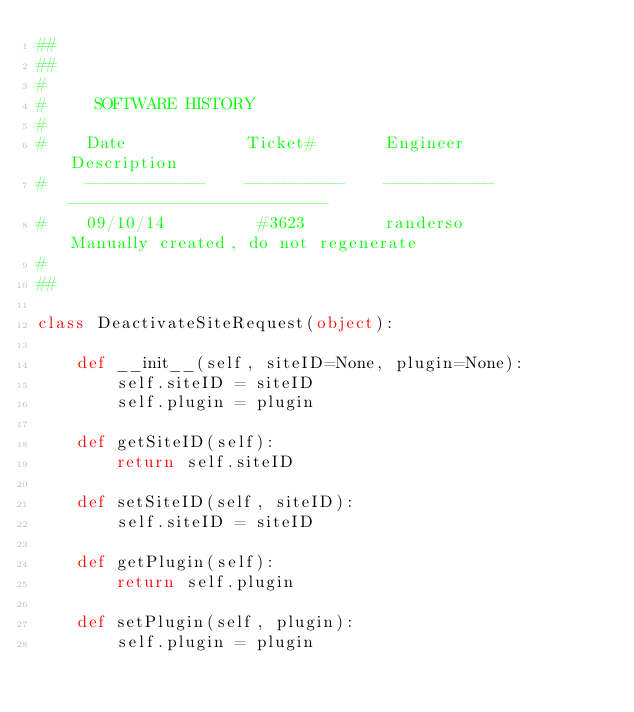<code> <loc_0><loc_0><loc_500><loc_500><_Python_>##
##
#
#     SOFTWARE HISTORY
#
#    Date            Ticket#       Engineer       Description
#    ------------    ----------    -----------    --------------------------
#    09/10/14         #3623        randerso       Manually created, do not regenerate
#
##

class DeactivateSiteRequest(object):

    def __init__(self, siteID=None, plugin=None):
        self.siteID = siteID
        self.plugin = plugin

    def getSiteID(self):
        return self.siteID

    def setSiteID(self, siteID):
        self.siteID = siteID

    def getPlugin(self):
        return self.plugin

    def setPlugin(self, plugin):
        self.plugin = plugin
</code> 